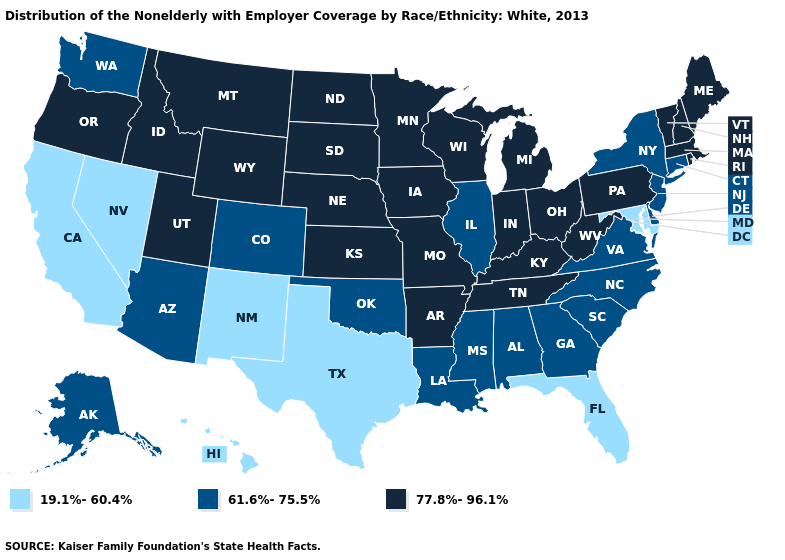Is the legend a continuous bar?
Answer briefly. No. Which states hav the highest value in the West?
Answer briefly. Idaho, Montana, Oregon, Utah, Wyoming. What is the highest value in the MidWest ?
Be succinct. 77.8%-96.1%. Name the states that have a value in the range 19.1%-60.4%?
Concise answer only. California, Florida, Hawaii, Maryland, Nevada, New Mexico, Texas. Is the legend a continuous bar?
Give a very brief answer. No. Does South Dakota have a higher value than Texas?
Give a very brief answer. Yes. What is the highest value in the MidWest ?
Quick response, please. 77.8%-96.1%. What is the value of Utah?
Be succinct. 77.8%-96.1%. What is the value of North Carolina?
Keep it brief. 61.6%-75.5%. Name the states that have a value in the range 77.8%-96.1%?
Short answer required. Arkansas, Idaho, Indiana, Iowa, Kansas, Kentucky, Maine, Massachusetts, Michigan, Minnesota, Missouri, Montana, Nebraska, New Hampshire, North Dakota, Ohio, Oregon, Pennsylvania, Rhode Island, South Dakota, Tennessee, Utah, Vermont, West Virginia, Wisconsin, Wyoming. Name the states that have a value in the range 61.6%-75.5%?
Give a very brief answer. Alabama, Alaska, Arizona, Colorado, Connecticut, Delaware, Georgia, Illinois, Louisiana, Mississippi, New Jersey, New York, North Carolina, Oklahoma, South Carolina, Virginia, Washington. Name the states that have a value in the range 61.6%-75.5%?
Quick response, please. Alabama, Alaska, Arizona, Colorado, Connecticut, Delaware, Georgia, Illinois, Louisiana, Mississippi, New Jersey, New York, North Carolina, Oklahoma, South Carolina, Virginia, Washington. Is the legend a continuous bar?
Give a very brief answer. No. Name the states that have a value in the range 19.1%-60.4%?
Write a very short answer. California, Florida, Hawaii, Maryland, Nevada, New Mexico, Texas. Name the states that have a value in the range 77.8%-96.1%?
Keep it brief. Arkansas, Idaho, Indiana, Iowa, Kansas, Kentucky, Maine, Massachusetts, Michigan, Minnesota, Missouri, Montana, Nebraska, New Hampshire, North Dakota, Ohio, Oregon, Pennsylvania, Rhode Island, South Dakota, Tennessee, Utah, Vermont, West Virginia, Wisconsin, Wyoming. 